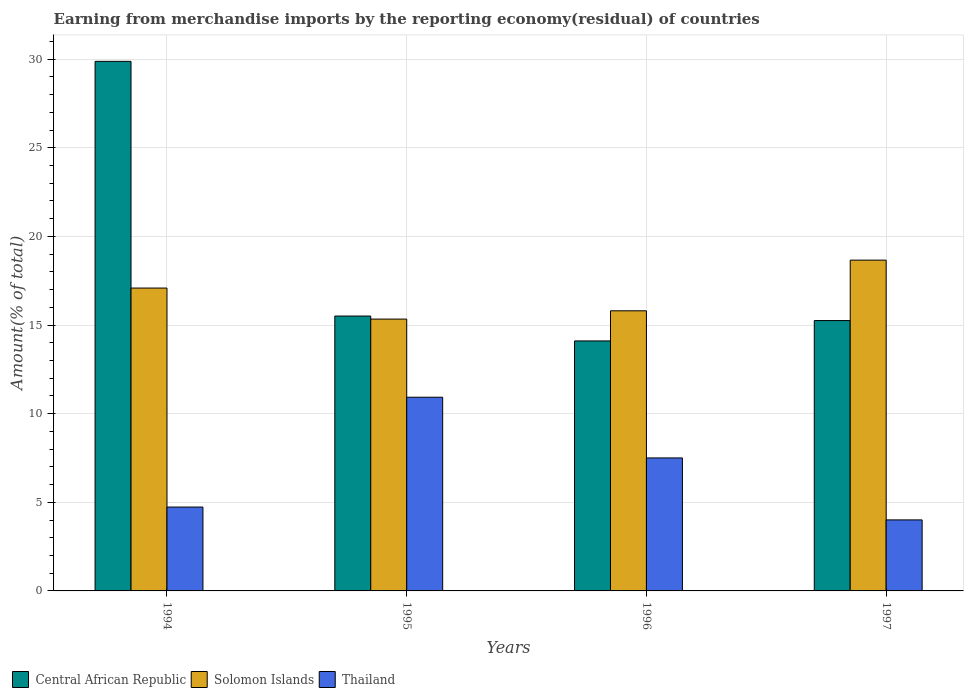What is the percentage of amount earned from merchandise imports in Solomon Islands in 1995?
Your answer should be compact. 15.33. Across all years, what is the maximum percentage of amount earned from merchandise imports in Central African Republic?
Give a very brief answer. 29.87. Across all years, what is the minimum percentage of amount earned from merchandise imports in Thailand?
Keep it short and to the point. 4.01. What is the total percentage of amount earned from merchandise imports in Solomon Islands in the graph?
Provide a short and direct response. 66.88. What is the difference between the percentage of amount earned from merchandise imports in Solomon Islands in 1995 and that in 1997?
Make the answer very short. -3.33. What is the difference between the percentage of amount earned from merchandise imports in Thailand in 1996 and the percentage of amount earned from merchandise imports in Solomon Islands in 1995?
Provide a succinct answer. -7.83. What is the average percentage of amount earned from merchandise imports in Thailand per year?
Your answer should be very brief. 6.79. In the year 1995, what is the difference between the percentage of amount earned from merchandise imports in Central African Republic and percentage of amount earned from merchandise imports in Solomon Islands?
Your response must be concise. 0.17. In how many years, is the percentage of amount earned from merchandise imports in Thailand greater than 25 %?
Ensure brevity in your answer.  0. What is the ratio of the percentage of amount earned from merchandise imports in Solomon Islands in 1994 to that in 1996?
Provide a succinct answer. 1.08. What is the difference between the highest and the second highest percentage of amount earned from merchandise imports in Central African Republic?
Your answer should be very brief. 14.37. What is the difference between the highest and the lowest percentage of amount earned from merchandise imports in Solomon Islands?
Provide a short and direct response. 3.33. In how many years, is the percentage of amount earned from merchandise imports in Central African Republic greater than the average percentage of amount earned from merchandise imports in Central African Republic taken over all years?
Keep it short and to the point. 1. What does the 2nd bar from the left in 1996 represents?
Make the answer very short. Solomon Islands. What does the 2nd bar from the right in 1997 represents?
Ensure brevity in your answer.  Solomon Islands. Is it the case that in every year, the sum of the percentage of amount earned from merchandise imports in Solomon Islands and percentage of amount earned from merchandise imports in Central African Republic is greater than the percentage of amount earned from merchandise imports in Thailand?
Your response must be concise. Yes. How many years are there in the graph?
Ensure brevity in your answer.  4. Does the graph contain grids?
Provide a short and direct response. Yes. Where does the legend appear in the graph?
Ensure brevity in your answer.  Bottom left. What is the title of the graph?
Provide a short and direct response. Earning from merchandise imports by the reporting economy(residual) of countries. Does "Romania" appear as one of the legend labels in the graph?
Ensure brevity in your answer.  No. What is the label or title of the Y-axis?
Your answer should be very brief. Amount(% of total). What is the Amount(% of total) of Central African Republic in 1994?
Provide a short and direct response. 29.87. What is the Amount(% of total) of Solomon Islands in 1994?
Give a very brief answer. 17.09. What is the Amount(% of total) of Thailand in 1994?
Offer a very short reply. 4.73. What is the Amount(% of total) of Central African Republic in 1995?
Your answer should be very brief. 15.51. What is the Amount(% of total) of Solomon Islands in 1995?
Provide a succinct answer. 15.33. What is the Amount(% of total) of Thailand in 1995?
Provide a short and direct response. 10.93. What is the Amount(% of total) of Central African Republic in 1996?
Ensure brevity in your answer.  14.1. What is the Amount(% of total) of Solomon Islands in 1996?
Provide a succinct answer. 15.8. What is the Amount(% of total) of Thailand in 1996?
Offer a very short reply. 7.5. What is the Amount(% of total) in Central African Republic in 1997?
Your response must be concise. 15.25. What is the Amount(% of total) in Solomon Islands in 1997?
Ensure brevity in your answer.  18.66. What is the Amount(% of total) of Thailand in 1997?
Offer a very short reply. 4.01. Across all years, what is the maximum Amount(% of total) in Central African Republic?
Make the answer very short. 29.87. Across all years, what is the maximum Amount(% of total) in Solomon Islands?
Keep it short and to the point. 18.66. Across all years, what is the maximum Amount(% of total) in Thailand?
Provide a succinct answer. 10.93. Across all years, what is the minimum Amount(% of total) of Central African Republic?
Make the answer very short. 14.1. Across all years, what is the minimum Amount(% of total) of Solomon Islands?
Ensure brevity in your answer.  15.33. Across all years, what is the minimum Amount(% of total) in Thailand?
Provide a succinct answer. 4.01. What is the total Amount(% of total) in Central African Republic in the graph?
Keep it short and to the point. 74.74. What is the total Amount(% of total) of Solomon Islands in the graph?
Offer a terse response. 66.88. What is the total Amount(% of total) in Thailand in the graph?
Your answer should be very brief. 27.17. What is the difference between the Amount(% of total) of Central African Republic in 1994 and that in 1995?
Provide a succinct answer. 14.37. What is the difference between the Amount(% of total) of Solomon Islands in 1994 and that in 1995?
Offer a terse response. 1.75. What is the difference between the Amount(% of total) of Thailand in 1994 and that in 1995?
Your answer should be compact. -6.2. What is the difference between the Amount(% of total) of Central African Republic in 1994 and that in 1996?
Your response must be concise. 15.77. What is the difference between the Amount(% of total) in Solomon Islands in 1994 and that in 1996?
Your answer should be compact. 1.28. What is the difference between the Amount(% of total) in Thailand in 1994 and that in 1996?
Provide a short and direct response. -2.77. What is the difference between the Amount(% of total) in Central African Republic in 1994 and that in 1997?
Give a very brief answer. 14.62. What is the difference between the Amount(% of total) in Solomon Islands in 1994 and that in 1997?
Your answer should be very brief. -1.58. What is the difference between the Amount(% of total) of Thailand in 1994 and that in 1997?
Your answer should be compact. 0.73. What is the difference between the Amount(% of total) of Central African Republic in 1995 and that in 1996?
Give a very brief answer. 1.4. What is the difference between the Amount(% of total) of Solomon Islands in 1995 and that in 1996?
Make the answer very short. -0.47. What is the difference between the Amount(% of total) in Thailand in 1995 and that in 1996?
Provide a succinct answer. 3.42. What is the difference between the Amount(% of total) of Central African Republic in 1995 and that in 1997?
Make the answer very short. 0.26. What is the difference between the Amount(% of total) of Solomon Islands in 1995 and that in 1997?
Your answer should be compact. -3.33. What is the difference between the Amount(% of total) of Thailand in 1995 and that in 1997?
Your response must be concise. 6.92. What is the difference between the Amount(% of total) in Central African Republic in 1996 and that in 1997?
Offer a very short reply. -1.15. What is the difference between the Amount(% of total) in Solomon Islands in 1996 and that in 1997?
Offer a terse response. -2.86. What is the difference between the Amount(% of total) of Thailand in 1996 and that in 1997?
Your response must be concise. 3.5. What is the difference between the Amount(% of total) of Central African Republic in 1994 and the Amount(% of total) of Solomon Islands in 1995?
Offer a terse response. 14.54. What is the difference between the Amount(% of total) of Central African Republic in 1994 and the Amount(% of total) of Thailand in 1995?
Give a very brief answer. 18.95. What is the difference between the Amount(% of total) in Solomon Islands in 1994 and the Amount(% of total) in Thailand in 1995?
Keep it short and to the point. 6.16. What is the difference between the Amount(% of total) in Central African Republic in 1994 and the Amount(% of total) in Solomon Islands in 1996?
Your answer should be compact. 14.07. What is the difference between the Amount(% of total) of Central African Republic in 1994 and the Amount(% of total) of Thailand in 1996?
Ensure brevity in your answer.  22.37. What is the difference between the Amount(% of total) of Solomon Islands in 1994 and the Amount(% of total) of Thailand in 1996?
Offer a terse response. 9.58. What is the difference between the Amount(% of total) in Central African Republic in 1994 and the Amount(% of total) in Solomon Islands in 1997?
Keep it short and to the point. 11.21. What is the difference between the Amount(% of total) in Central African Republic in 1994 and the Amount(% of total) in Thailand in 1997?
Give a very brief answer. 25.87. What is the difference between the Amount(% of total) in Solomon Islands in 1994 and the Amount(% of total) in Thailand in 1997?
Offer a very short reply. 13.08. What is the difference between the Amount(% of total) of Central African Republic in 1995 and the Amount(% of total) of Solomon Islands in 1996?
Offer a terse response. -0.3. What is the difference between the Amount(% of total) of Central African Republic in 1995 and the Amount(% of total) of Thailand in 1996?
Provide a short and direct response. 8. What is the difference between the Amount(% of total) in Solomon Islands in 1995 and the Amount(% of total) in Thailand in 1996?
Keep it short and to the point. 7.83. What is the difference between the Amount(% of total) of Central African Republic in 1995 and the Amount(% of total) of Solomon Islands in 1997?
Your response must be concise. -3.15. What is the difference between the Amount(% of total) in Central African Republic in 1995 and the Amount(% of total) in Thailand in 1997?
Your answer should be compact. 11.5. What is the difference between the Amount(% of total) of Solomon Islands in 1995 and the Amount(% of total) of Thailand in 1997?
Offer a terse response. 11.33. What is the difference between the Amount(% of total) of Central African Republic in 1996 and the Amount(% of total) of Solomon Islands in 1997?
Your response must be concise. -4.56. What is the difference between the Amount(% of total) in Central African Republic in 1996 and the Amount(% of total) in Thailand in 1997?
Offer a very short reply. 10.1. What is the difference between the Amount(% of total) in Solomon Islands in 1996 and the Amount(% of total) in Thailand in 1997?
Your response must be concise. 11.8. What is the average Amount(% of total) of Central African Republic per year?
Ensure brevity in your answer.  18.68. What is the average Amount(% of total) in Solomon Islands per year?
Your response must be concise. 16.72. What is the average Amount(% of total) of Thailand per year?
Your response must be concise. 6.79. In the year 1994, what is the difference between the Amount(% of total) of Central African Republic and Amount(% of total) of Solomon Islands?
Your answer should be very brief. 12.79. In the year 1994, what is the difference between the Amount(% of total) in Central African Republic and Amount(% of total) in Thailand?
Ensure brevity in your answer.  25.14. In the year 1994, what is the difference between the Amount(% of total) in Solomon Islands and Amount(% of total) in Thailand?
Keep it short and to the point. 12.35. In the year 1995, what is the difference between the Amount(% of total) of Central African Republic and Amount(% of total) of Solomon Islands?
Your answer should be very brief. 0.17. In the year 1995, what is the difference between the Amount(% of total) in Central African Republic and Amount(% of total) in Thailand?
Ensure brevity in your answer.  4.58. In the year 1995, what is the difference between the Amount(% of total) of Solomon Islands and Amount(% of total) of Thailand?
Provide a succinct answer. 4.41. In the year 1996, what is the difference between the Amount(% of total) in Central African Republic and Amount(% of total) in Solomon Islands?
Ensure brevity in your answer.  -1.7. In the year 1996, what is the difference between the Amount(% of total) of Central African Republic and Amount(% of total) of Thailand?
Your response must be concise. 6.6. In the year 1996, what is the difference between the Amount(% of total) in Solomon Islands and Amount(% of total) in Thailand?
Provide a succinct answer. 8.3. In the year 1997, what is the difference between the Amount(% of total) in Central African Republic and Amount(% of total) in Solomon Islands?
Your answer should be compact. -3.41. In the year 1997, what is the difference between the Amount(% of total) in Central African Republic and Amount(% of total) in Thailand?
Your answer should be compact. 11.25. In the year 1997, what is the difference between the Amount(% of total) of Solomon Islands and Amount(% of total) of Thailand?
Provide a succinct answer. 14.65. What is the ratio of the Amount(% of total) in Central African Republic in 1994 to that in 1995?
Provide a succinct answer. 1.93. What is the ratio of the Amount(% of total) of Solomon Islands in 1994 to that in 1995?
Ensure brevity in your answer.  1.11. What is the ratio of the Amount(% of total) in Thailand in 1994 to that in 1995?
Ensure brevity in your answer.  0.43. What is the ratio of the Amount(% of total) of Central African Republic in 1994 to that in 1996?
Make the answer very short. 2.12. What is the ratio of the Amount(% of total) of Solomon Islands in 1994 to that in 1996?
Make the answer very short. 1.08. What is the ratio of the Amount(% of total) of Thailand in 1994 to that in 1996?
Your response must be concise. 0.63. What is the ratio of the Amount(% of total) in Central African Republic in 1994 to that in 1997?
Your answer should be very brief. 1.96. What is the ratio of the Amount(% of total) in Solomon Islands in 1994 to that in 1997?
Give a very brief answer. 0.92. What is the ratio of the Amount(% of total) in Thailand in 1994 to that in 1997?
Keep it short and to the point. 1.18. What is the ratio of the Amount(% of total) of Central African Republic in 1995 to that in 1996?
Offer a terse response. 1.1. What is the ratio of the Amount(% of total) of Solomon Islands in 1995 to that in 1996?
Give a very brief answer. 0.97. What is the ratio of the Amount(% of total) in Thailand in 1995 to that in 1996?
Provide a succinct answer. 1.46. What is the ratio of the Amount(% of total) of Central African Republic in 1995 to that in 1997?
Ensure brevity in your answer.  1.02. What is the ratio of the Amount(% of total) of Solomon Islands in 1995 to that in 1997?
Provide a short and direct response. 0.82. What is the ratio of the Amount(% of total) in Thailand in 1995 to that in 1997?
Your response must be concise. 2.73. What is the ratio of the Amount(% of total) in Central African Republic in 1996 to that in 1997?
Provide a short and direct response. 0.92. What is the ratio of the Amount(% of total) of Solomon Islands in 1996 to that in 1997?
Your answer should be very brief. 0.85. What is the ratio of the Amount(% of total) in Thailand in 1996 to that in 1997?
Your answer should be compact. 1.87. What is the difference between the highest and the second highest Amount(% of total) of Central African Republic?
Keep it short and to the point. 14.37. What is the difference between the highest and the second highest Amount(% of total) of Solomon Islands?
Your answer should be compact. 1.58. What is the difference between the highest and the second highest Amount(% of total) in Thailand?
Offer a terse response. 3.42. What is the difference between the highest and the lowest Amount(% of total) in Central African Republic?
Your response must be concise. 15.77. What is the difference between the highest and the lowest Amount(% of total) of Solomon Islands?
Provide a succinct answer. 3.33. What is the difference between the highest and the lowest Amount(% of total) of Thailand?
Provide a succinct answer. 6.92. 